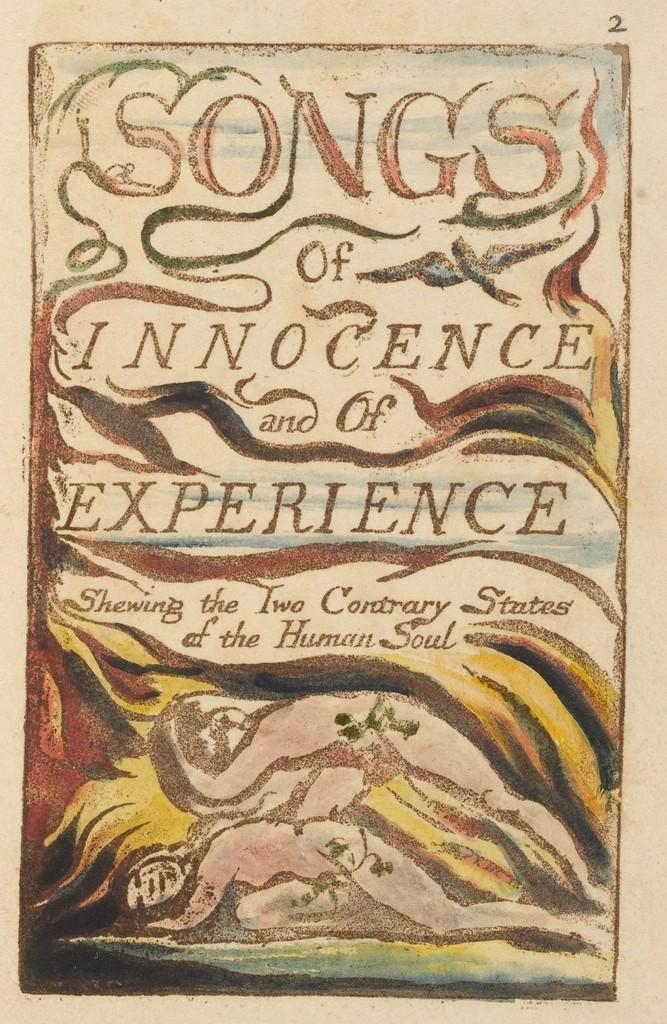<image>
Write a terse but informative summary of the picture. A book called Songs of Innocence and of Experience. 